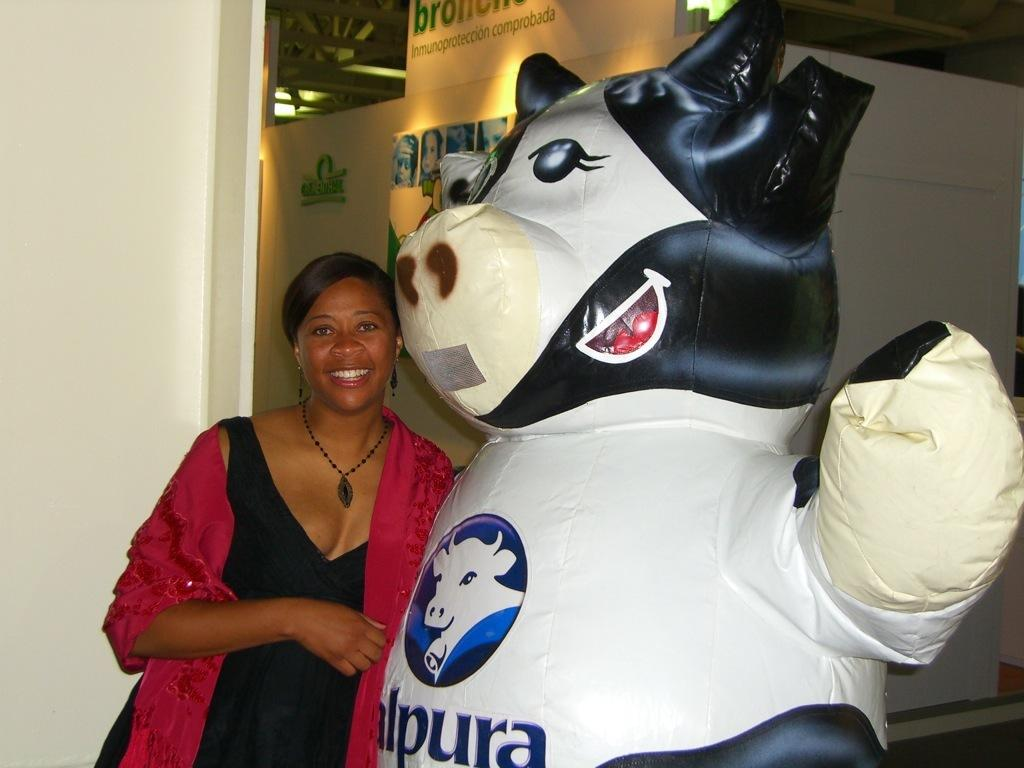<image>
Give a short and clear explanation of the subsequent image. a woman next to a cow figure with letter l, p, u, r and a on its chest 